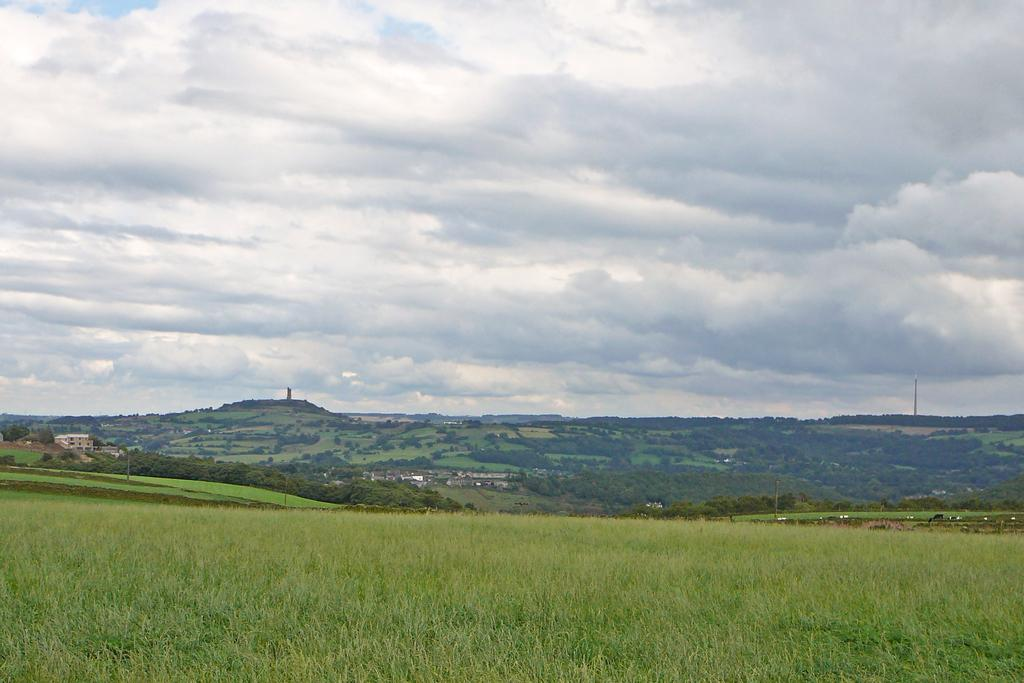What type of vegetation is at the bottom of the image? There is grass at the bottom of the image. What structure is located on the left side of the image? There is a building on the left side of the image. What can be seen in the background of the image? There are trees in the background of the image. What is visible at the top of the image? The sky is visible at the top of the image. Where is the brain located in the image? There is no brain present in the image. What type of produce is being harvested in the image? There is no produce or harvesting activity depicted in the image. 